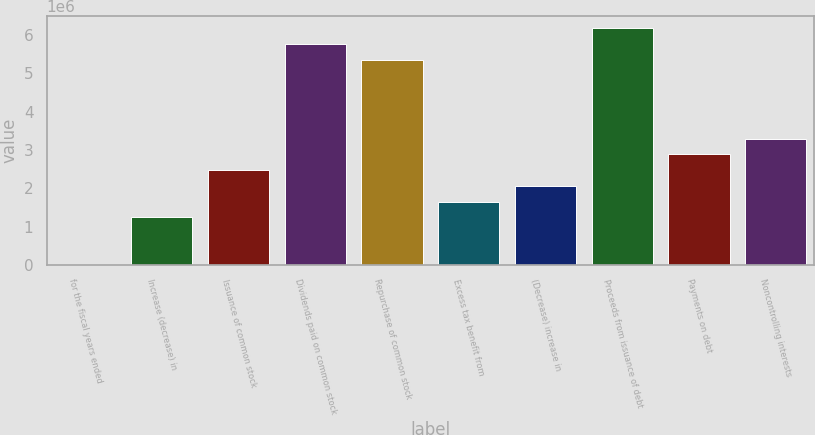Convert chart. <chart><loc_0><loc_0><loc_500><loc_500><bar_chart><fcel>for the fiscal years ended<fcel>Increase (decrease) in<fcel>Issuance of common stock<fcel>Dividends paid on common stock<fcel>Repurchase of common stock<fcel>Excess tax benefit from<fcel>(Decrease) increase in<fcel>Proceeds from issuance of debt<fcel>Payments on debt<fcel>Noncontrolling interests<nl><fcel>2010<fcel>1.23852e+06<fcel>2.47503e+06<fcel>5.7724e+06<fcel>5.36023e+06<fcel>1.65069e+06<fcel>2.06286e+06<fcel>6.18457e+06<fcel>2.8872e+06<fcel>3.29937e+06<nl></chart> 